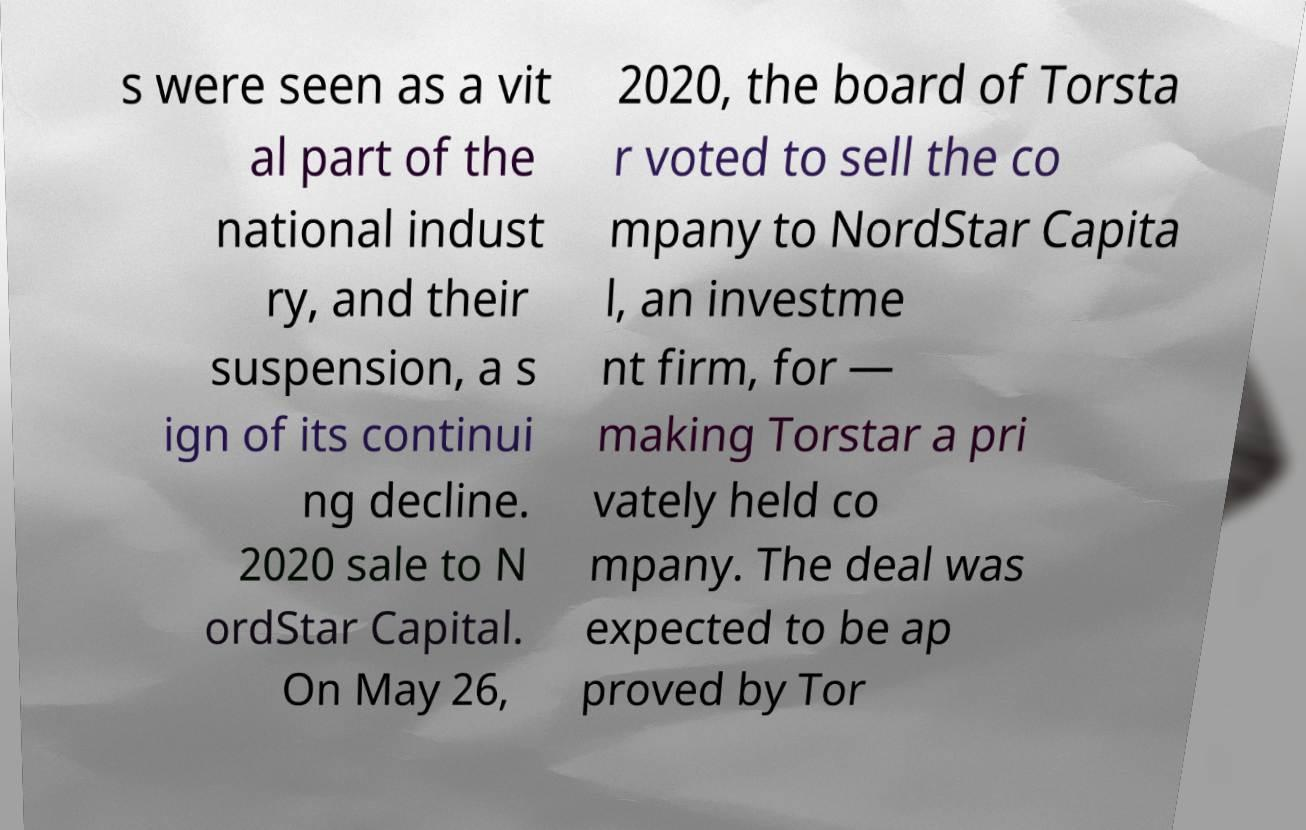Could you assist in decoding the text presented in this image and type it out clearly? s were seen as a vit al part of the national indust ry, and their suspension, a s ign of its continui ng decline. 2020 sale to N ordStar Capital. On May 26, 2020, the board of Torsta r voted to sell the co mpany to NordStar Capita l, an investme nt firm, for — making Torstar a pri vately held co mpany. The deal was expected to be ap proved by Tor 